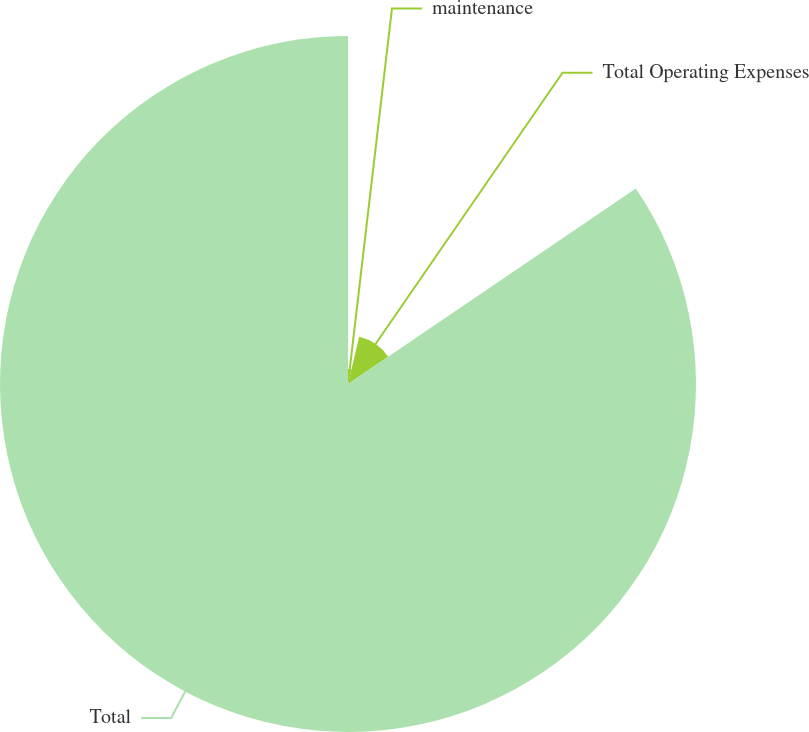<chart> <loc_0><loc_0><loc_500><loc_500><pie_chart><fcel>maintenance<fcel>Total Operating Expenses<fcel>Total<nl><fcel>3.71%<fcel>11.79%<fcel>84.5%<nl></chart> 